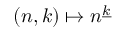<formula> <loc_0><loc_0><loc_500><loc_500>( n , k ) \mapsto n ^ { \underline { k } }</formula> 